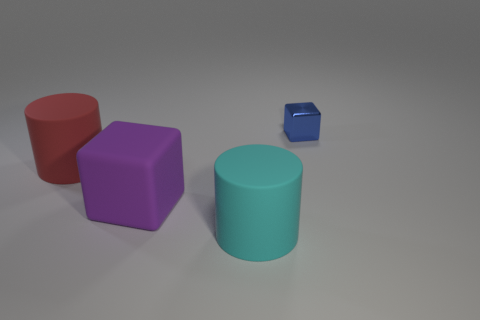Are there any other things that are made of the same material as the blue block?
Give a very brief answer. No. There is a cyan cylinder that is the same size as the red rubber cylinder; what is its material?
Provide a short and direct response. Rubber. Is the number of red cylinders in front of the cyan object the same as the number of things that are to the left of the big red matte cylinder?
Provide a short and direct response. Yes. There is a big cylinder that is on the left side of the rubber cylinder that is in front of the red thing; how many tiny objects are in front of it?
Provide a short and direct response. 0. Is the color of the tiny block the same as the large matte cylinder to the right of the red matte cylinder?
Your answer should be very brief. No. The cyan cylinder that is made of the same material as the large cube is what size?
Provide a short and direct response. Large. Are there more big matte cylinders that are to the right of the blue metallic cube than metallic blocks?
Offer a very short reply. No. The cylinder right of the cube that is to the left of the matte cylinder that is to the right of the red object is made of what material?
Your answer should be compact. Rubber. Do the purple thing and the large cylinder on the right side of the large red thing have the same material?
Your answer should be compact. Yes. There is another object that is the same shape as the red rubber object; what material is it?
Give a very brief answer. Rubber. 